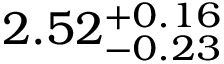<formula> <loc_0><loc_0><loc_500><loc_500>2 . 5 2 _ { - 0 . 2 3 } ^ { + 0 . 1 6 }</formula> 